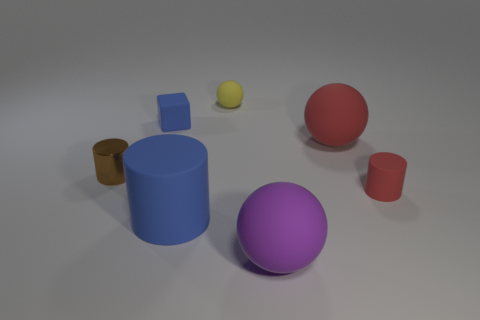Subtract all large matte spheres. How many spheres are left? 1 Add 2 metallic objects. How many objects exist? 9 Subtract all brown cylinders. How many cylinders are left? 2 Subtract all small purple matte balls. Subtract all small red cylinders. How many objects are left? 6 Add 5 metal objects. How many metal objects are left? 6 Add 4 tiny brown things. How many tiny brown things exist? 5 Subtract 0 cyan cubes. How many objects are left? 7 Subtract all cylinders. How many objects are left? 4 Subtract 3 cylinders. How many cylinders are left? 0 Subtract all yellow blocks. Subtract all purple spheres. How many blocks are left? 1 